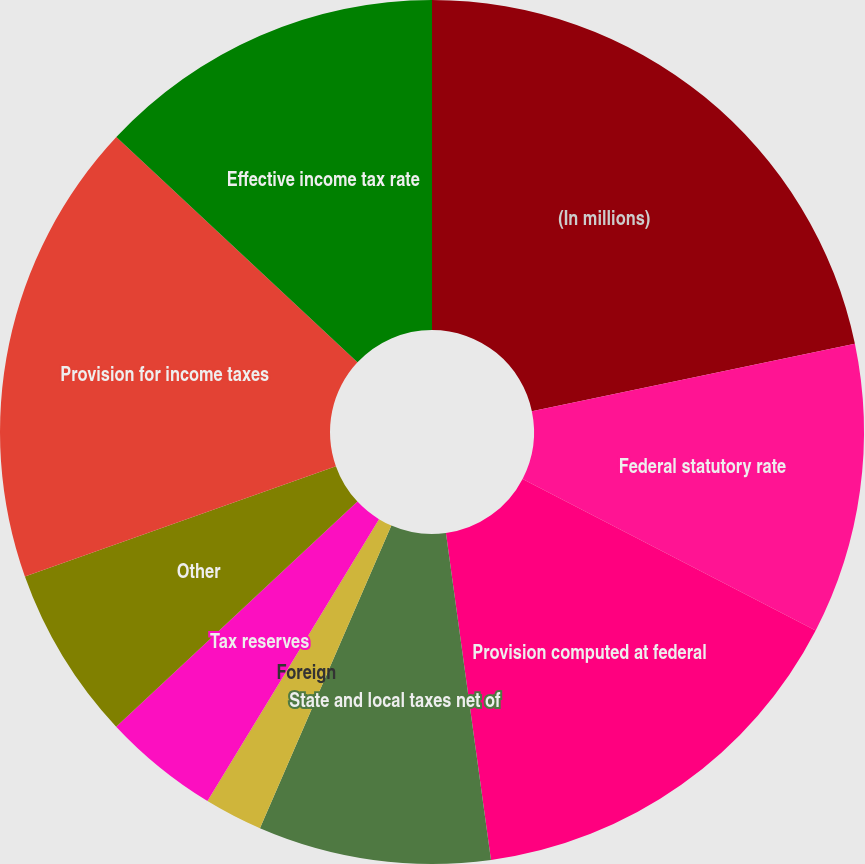Convert chart. <chart><loc_0><loc_0><loc_500><loc_500><pie_chart><fcel>(In millions)<fcel>Federal statutory rate<fcel>Provision computed at federal<fcel>State and local taxes net of<fcel>Foreign<fcel>Valuation allowance<fcel>Tax reserves<fcel>Other<fcel>Provision for income taxes<fcel>Effective income tax rate<nl><fcel>21.73%<fcel>10.87%<fcel>15.22%<fcel>8.7%<fcel>2.18%<fcel>0.0%<fcel>4.35%<fcel>6.52%<fcel>17.39%<fcel>13.04%<nl></chart> 